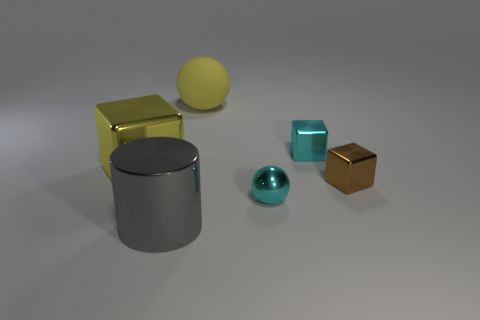Add 1 cubes. How many objects exist? 7 Subtract all cylinders. How many objects are left? 5 Subtract all yellow matte cubes. Subtract all metallic cylinders. How many objects are left? 5 Add 2 metallic blocks. How many metallic blocks are left? 5 Add 4 big blue matte cubes. How many big blue matte cubes exist? 4 Subtract 0 blue cubes. How many objects are left? 6 